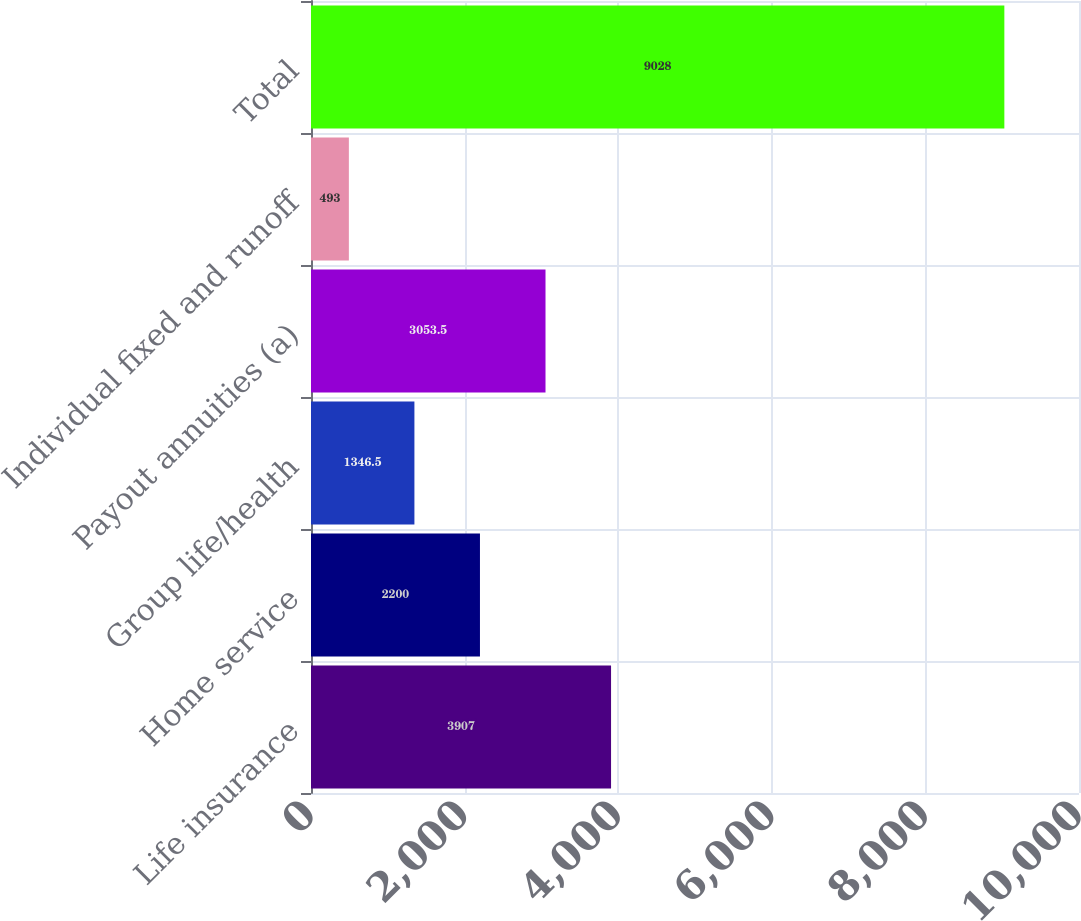Convert chart. <chart><loc_0><loc_0><loc_500><loc_500><bar_chart><fcel>Life insurance<fcel>Home service<fcel>Group life/health<fcel>Payout annuities (a)<fcel>Individual fixed and runoff<fcel>Total<nl><fcel>3907<fcel>2200<fcel>1346.5<fcel>3053.5<fcel>493<fcel>9028<nl></chart> 